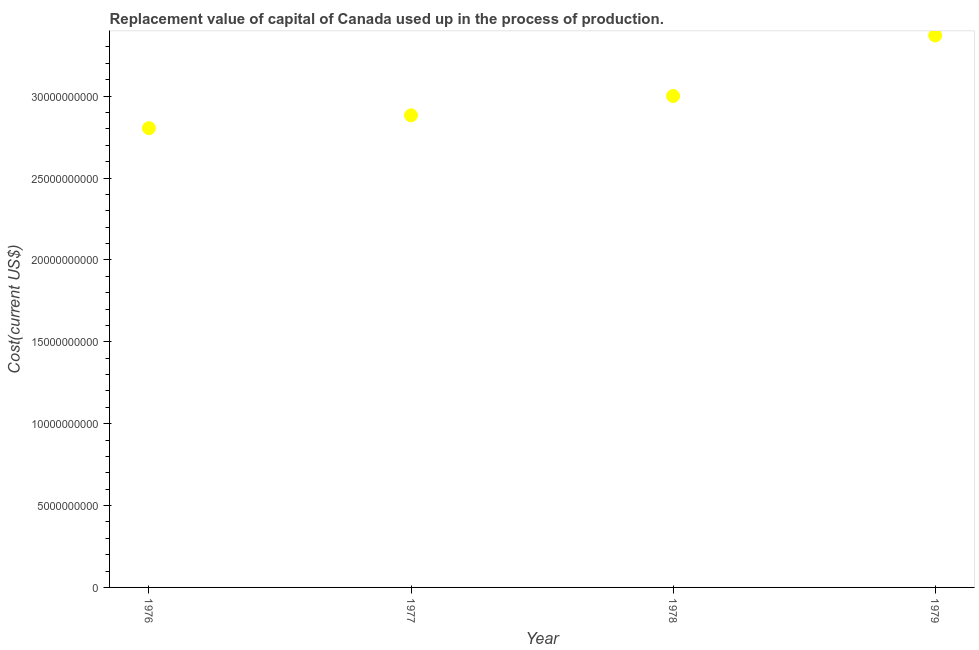What is the consumption of fixed capital in 1979?
Your response must be concise. 3.37e+1. Across all years, what is the maximum consumption of fixed capital?
Offer a very short reply. 3.37e+1. Across all years, what is the minimum consumption of fixed capital?
Your response must be concise. 2.80e+1. In which year was the consumption of fixed capital maximum?
Provide a succinct answer. 1979. In which year was the consumption of fixed capital minimum?
Offer a terse response. 1976. What is the sum of the consumption of fixed capital?
Offer a terse response. 1.21e+11. What is the difference between the consumption of fixed capital in 1976 and 1979?
Provide a succinct answer. -5.66e+09. What is the average consumption of fixed capital per year?
Ensure brevity in your answer.  3.01e+1. What is the median consumption of fixed capital?
Ensure brevity in your answer.  2.94e+1. Do a majority of the years between 1976 and 1978 (inclusive) have consumption of fixed capital greater than 19000000000 US$?
Your response must be concise. Yes. What is the ratio of the consumption of fixed capital in 1977 to that in 1979?
Your answer should be very brief. 0.86. Is the consumption of fixed capital in 1976 less than that in 1977?
Offer a very short reply. Yes. Is the difference between the consumption of fixed capital in 1977 and 1979 greater than the difference between any two years?
Provide a succinct answer. No. What is the difference between the highest and the second highest consumption of fixed capital?
Your answer should be very brief. 3.70e+09. Is the sum of the consumption of fixed capital in 1977 and 1978 greater than the maximum consumption of fixed capital across all years?
Provide a short and direct response. Yes. What is the difference between the highest and the lowest consumption of fixed capital?
Make the answer very short. 5.66e+09. Does the consumption of fixed capital monotonically increase over the years?
Your response must be concise. Yes. How many dotlines are there?
Provide a short and direct response. 1. How many years are there in the graph?
Ensure brevity in your answer.  4. Are the values on the major ticks of Y-axis written in scientific E-notation?
Your answer should be compact. No. Does the graph contain any zero values?
Keep it short and to the point. No. What is the title of the graph?
Provide a short and direct response. Replacement value of capital of Canada used up in the process of production. What is the label or title of the X-axis?
Ensure brevity in your answer.  Year. What is the label or title of the Y-axis?
Provide a short and direct response. Cost(current US$). What is the Cost(current US$) in 1976?
Offer a terse response. 2.80e+1. What is the Cost(current US$) in 1977?
Make the answer very short. 2.88e+1. What is the Cost(current US$) in 1978?
Ensure brevity in your answer.  3.00e+1. What is the Cost(current US$) in 1979?
Provide a short and direct response. 3.37e+1. What is the difference between the Cost(current US$) in 1976 and 1977?
Make the answer very short. -7.84e+08. What is the difference between the Cost(current US$) in 1976 and 1978?
Offer a terse response. -1.97e+09. What is the difference between the Cost(current US$) in 1976 and 1979?
Your answer should be compact. -5.66e+09. What is the difference between the Cost(current US$) in 1977 and 1978?
Offer a terse response. -1.18e+09. What is the difference between the Cost(current US$) in 1977 and 1979?
Provide a succinct answer. -4.88e+09. What is the difference between the Cost(current US$) in 1978 and 1979?
Your response must be concise. -3.70e+09. What is the ratio of the Cost(current US$) in 1976 to that in 1978?
Your answer should be very brief. 0.93. What is the ratio of the Cost(current US$) in 1976 to that in 1979?
Provide a succinct answer. 0.83. What is the ratio of the Cost(current US$) in 1977 to that in 1978?
Your answer should be compact. 0.96. What is the ratio of the Cost(current US$) in 1977 to that in 1979?
Give a very brief answer. 0.85. What is the ratio of the Cost(current US$) in 1978 to that in 1979?
Your response must be concise. 0.89. 